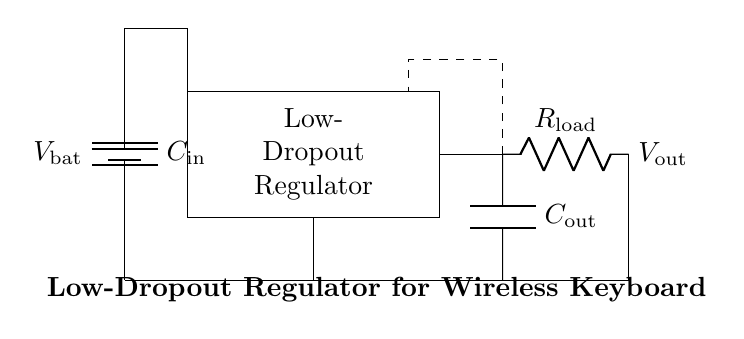What is the type of regulator used in this circuit? The circuit uses a low-dropout regulator, which is a type of voltage regulator designed to operate with a small input-output voltage difference. This is evident from the labeling of the rectangular component in the diagram.
Answer: low-dropout regulator What is the value of the output voltage labeled in the circuit? The output voltage is labeled as Vout in the circuit. However, the specific voltage value is not provided in the diagram itself, just that it is an output.
Answer: Vout How many capacitors are present in the circuit? There are two capacitors shown: one labeled as Cin and another labeled as Cout, indicating both input and output capacitors.
Answer: 2 What is the function of the load resistor in the circuit? The load resistor, labeled as Rload, provides a load for the regulator, which helps to regulate the output voltage. The circuit needs to show how the regulator performs under a specific load condition.
Answer: load What are the components connected to the ground? The components connected to ground are the battery, the output capacitor, and the load resistor as shown in the circuit connections from the bottom. They all return to the ground reference point.
Answer: battery, Cout, Rload Which component helps in smoothing the output voltage? The output capacitor, labeled as Cout, is responsible for smoothing out the fluctuations in the output voltage from the regulator, providing a stable voltage to the load.
Answer: Cout What is the purpose of the dashed feedback line in the diagram? The dashed feedback line represents the feedback mechanism used in the low-dropout regulator to maintain the desired output voltage. It plays a crucial role in the regulation process by adjusting the output based on the feedback it receives.
Answer: regulation feedback 